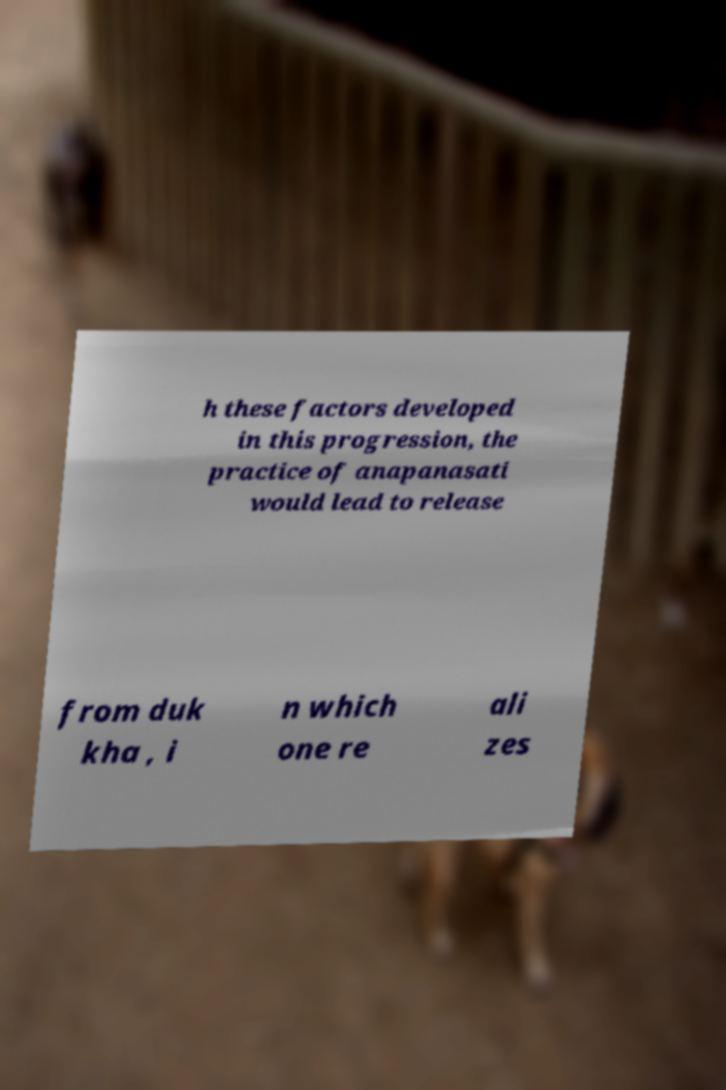Can you read and provide the text displayed in the image?This photo seems to have some interesting text. Can you extract and type it out for me? h these factors developed in this progression, the practice of anapanasati would lead to release from duk kha , i n which one re ali zes 